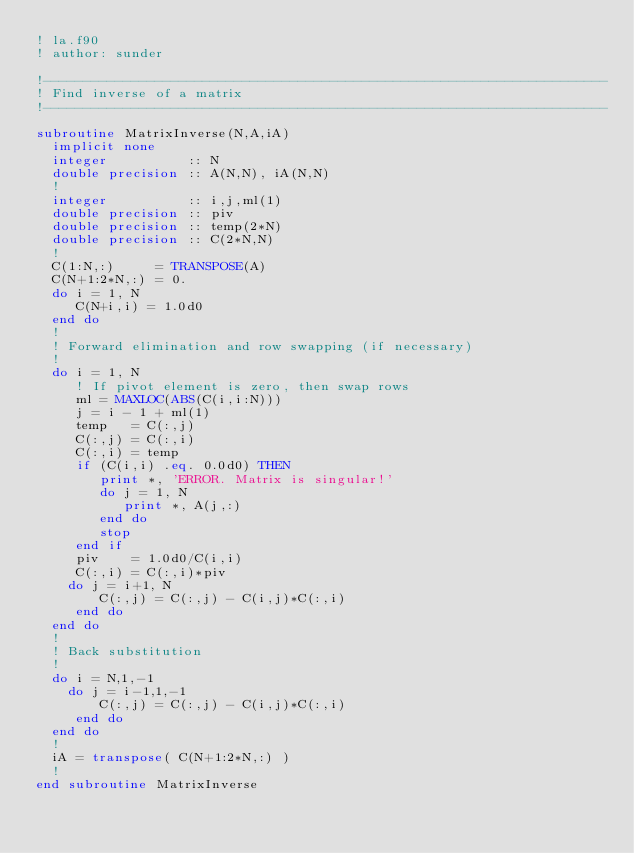<code> <loc_0><loc_0><loc_500><loc_500><_FORTRAN_>! la.f90
! author: sunder

!-----------------------------------------------------------------------
! Find inverse of a matrix
!-----------------------------------------------------------------------

subroutine MatrixInverse(N,A,iA)
  implicit none
  integer          :: N
  double precision :: A(N,N), iA(N,N)
  !
  integer          :: i,j,ml(1)
  double precision :: piv
  double precision :: temp(2*N)
  double precision :: C(2*N,N)
  !
  C(1:N,:)     = TRANSPOSE(A)
  C(N+1:2*N,:) = 0. 
  do i = 1, N
     C(N+i,i) = 1.0d0
  end do
  !    
  ! Forward elimination and row swapping (if necessary)
  ! 
  do i = 1, N
     ! If pivot element is zero, then swap rows 
     ml = MAXLOC(ABS(C(i,i:N))) 
     j = i - 1 + ml(1) 
     temp   = C(:,j) 
     C(:,j) = C(:,i)
     C(:,i) = temp      
     if (C(i,i) .eq. 0.0d0) THEN
        print *, 'ERROR. Matrix is singular!'
        do j = 1, N
           print *, A(j,:)
        end do
        stop
     end if
     piv    = 1.0d0/C(i,i)
     C(:,i) = C(:,i)*piv 
    do j = i+1, N
        C(:,j) = C(:,j) - C(i,j)*C(:,i)
     end do
  end do
  !
  ! Back substitution
  !
  do i = N,1,-1
    do j = i-1,1,-1
        C(:,j) = C(:,j) - C(i,j)*C(:,i)
     end do
  end do
  !
  iA = transpose( C(N+1:2*N,:) )
  !
end subroutine MatrixInverse
</code> 